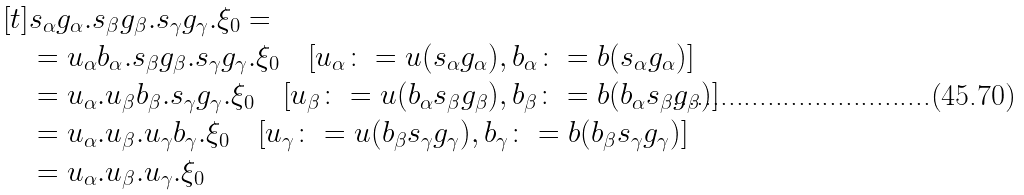Convert formula to latex. <formula><loc_0><loc_0><loc_500><loc_500>[ t ] & s _ { \alpha } g _ { \alpha } . s _ { \beta } g _ { \beta } . s _ { \gamma } g _ { \gamma } . \xi _ { 0 } = \\ & = u _ { \alpha } b _ { \alpha } . s _ { \beta } g _ { \beta } . s _ { \gamma } g _ { \gamma } . \xi _ { 0 } \quad [ u _ { \alpha } \colon = u ( s _ { \alpha } g _ { \alpha } ) , b _ { \alpha } \colon = b ( s _ { \alpha } g _ { \alpha } ) ] \\ & = u _ { \alpha } . u _ { \beta } b _ { \beta } . s _ { \gamma } g _ { \gamma } . \xi _ { 0 } \quad [ u _ { \beta } \colon = u ( b _ { \alpha } s _ { \beta } g _ { \beta } ) , b _ { \beta } \colon = b ( b _ { \alpha } s _ { \beta } g _ { \beta } ) ] \\ & = u _ { \alpha } . u _ { \beta } . u _ { \gamma } b _ { \gamma } . \xi _ { 0 } \quad [ u _ { \gamma } \colon = u ( b _ { \beta } s _ { \gamma } g _ { \gamma } ) , b _ { \gamma } \colon = b ( b _ { \beta } s _ { \gamma } g _ { \gamma } ) ] \\ & = u _ { \alpha } . u _ { \beta } . u _ { \gamma } . \xi _ { 0 }</formula> 